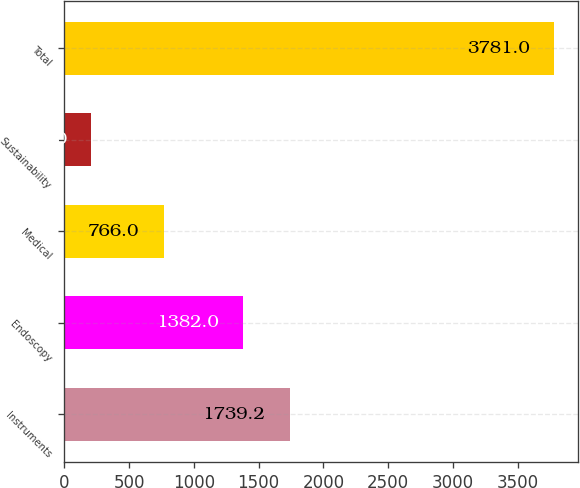Convert chart to OTSL. <chart><loc_0><loc_0><loc_500><loc_500><bar_chart><fcel>Instruments<fcel>Endoscopy<fcel>Medical<fcel>Sustainability<fcel>Total<nl><fcel>1739.2<fcel>1382<fcel>766<fcel>209<fcel>3781<nl></chart> 